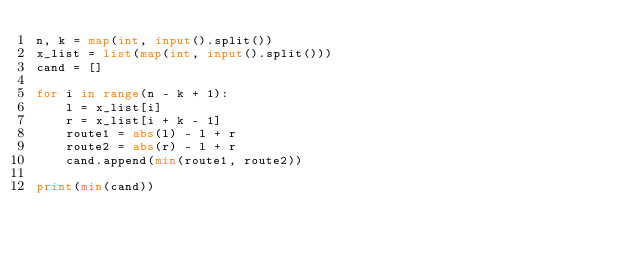<code> <loc_0><loc_0><loc_500><loc_500><_Python_>n, k = map(int, input().split())
x_list = list(map(int, input().split()))
cand = []

for i in range(n - k + 1):
    l = x_list[i]
    r = x_list[i + k - 1]
    route1 = abs(l) - l + r
    route2 = abs(r) - l + r
    cand.append(min(route1, route2))
    
print(min(cand))</code> 